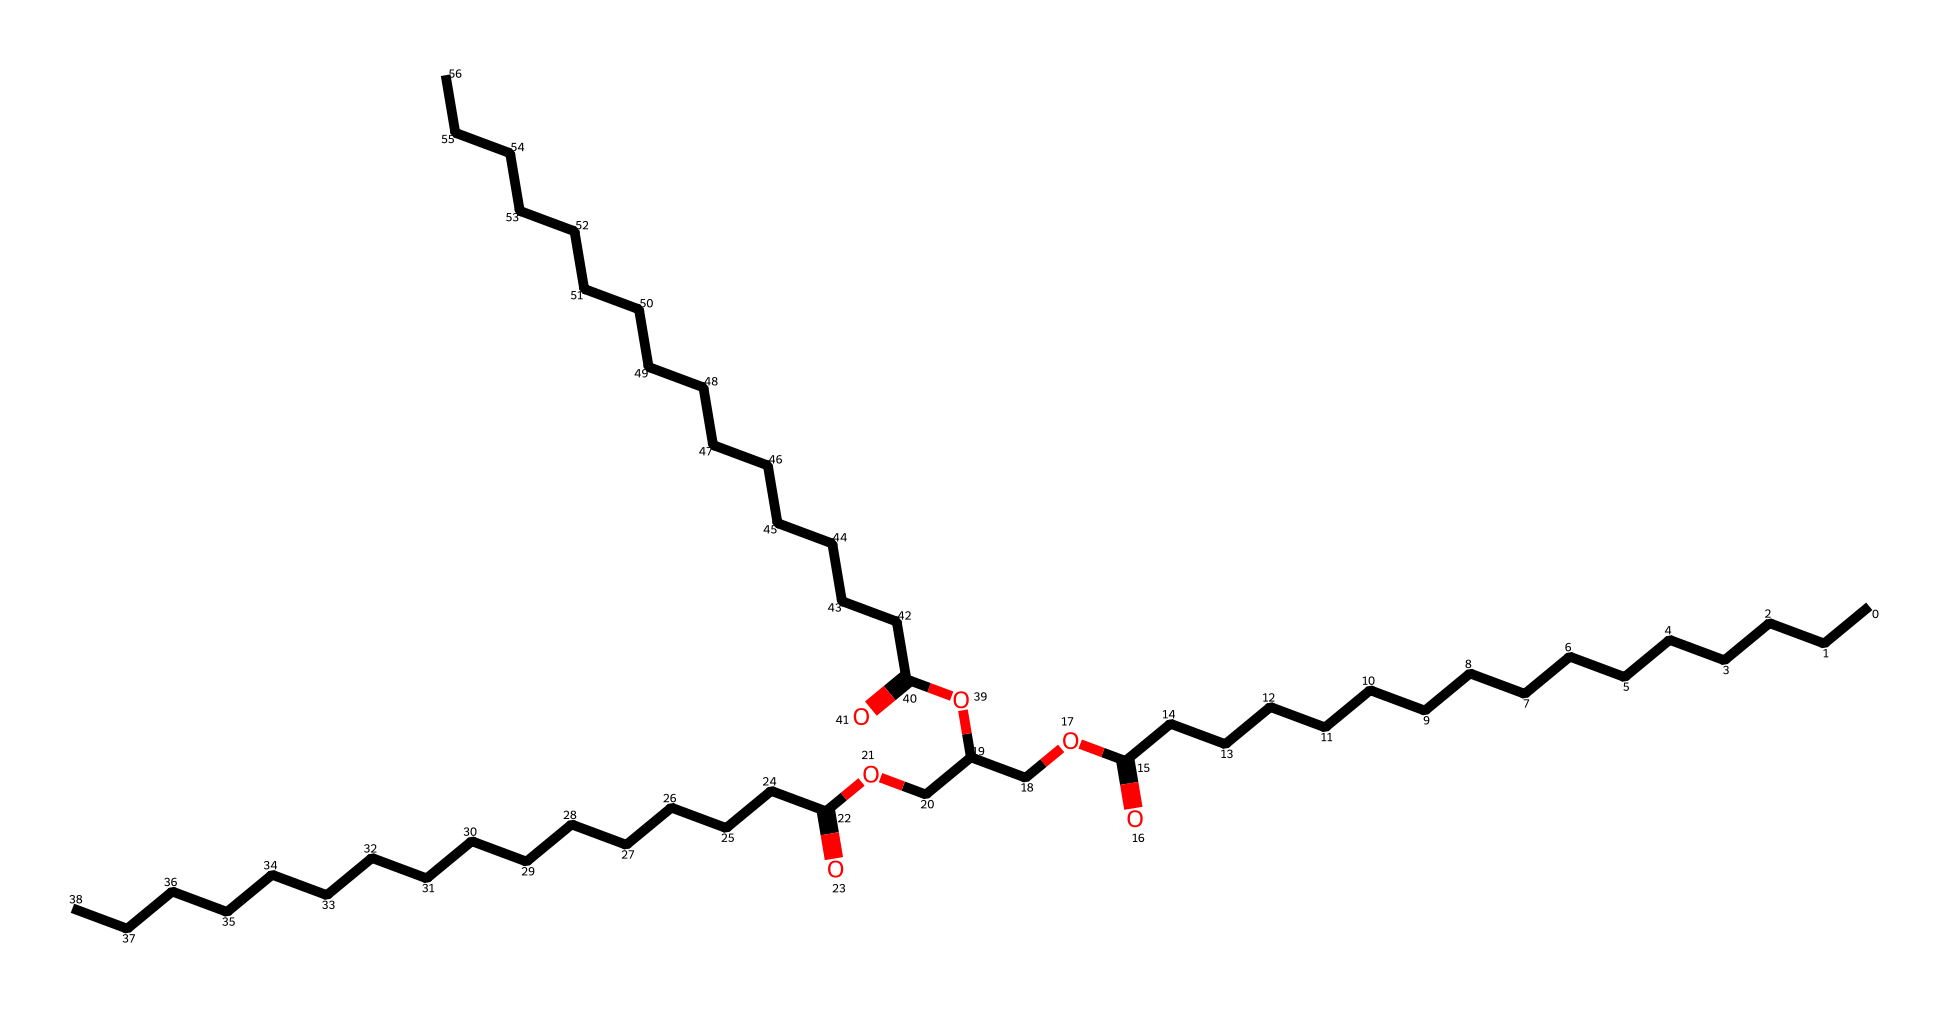What type of lipid is represented by this structure? The structure represents a triglyceride, which is indicated by the presence of three fatty acid chains attached to a glycerol backbone. Triglycerides are the main constituents of body fat in humans and animals, as well as vegetable fat.
Answer: triglyceride How many carbon atoms are in the structure? By analyzing the SMILES representation, we can count the carbon atoms based on the "C" occurrences in the structure. There are 35 carbon atoms in total when we account for each segment of the fatty acid chains linked to the glycerol.
Answer: 35 What functional groups are present in this lipid? The structure has carboxyl groups (-COOH), which are typical for fatty acids, and ester groups (–COO–), as indicated by the formation of esters with glycerol and fatty acids. This shows that the compound features both acidic and ester functional groups.
Answer: carboxyl and ester What is the approximate molecular weight of this compound? The molecular weight can be estimated by calculating the weights of all constituent atoms (C, H, O) in the structure. Given that the representation indicates a considerable number of carbon and oxygen atoms, the approximate molecular weight is calculated to be around 570 g/mol.
Answer: 570 What role do lipids like this play in coffee creamers? Lipids in dairy creamers primarily serve to provide creaminess and enhance mouthfeel in specialty coffee drinks. This contributes to the overall taste experience and richness of the beverage, making it more enjoyable for consumers.
Answer: creaminess How many ester linkages can be identified in the structure? Analyzing the structure reveals that there are three ester linkages, as triglycerides are formed by attaching three fatty acid chains to a glycerol molecule through esterification reactions. Each fatty acid contributes one ester bond in the overall structure.
Answer: three 